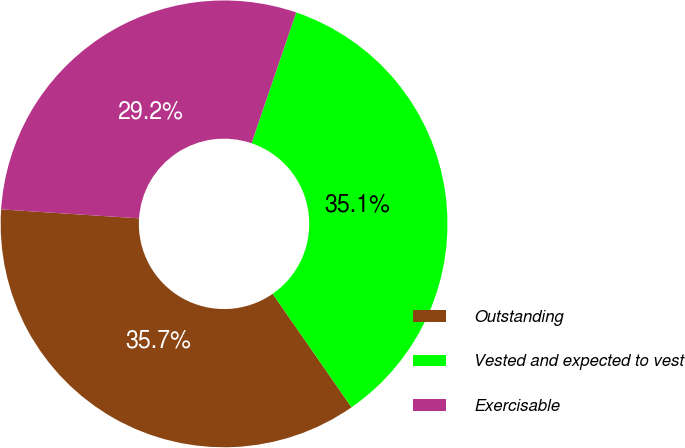Convert chart to OTSL. <chart><loc_0><loc_0><loc_500><loc_500><pie_chart><fcel>Outstanding<fcel>Vested and expected to vest<fcel>Exercisable<nl><fcel>35.7%<fcel>35.1%<fcel>29.2%<nl></chart> 